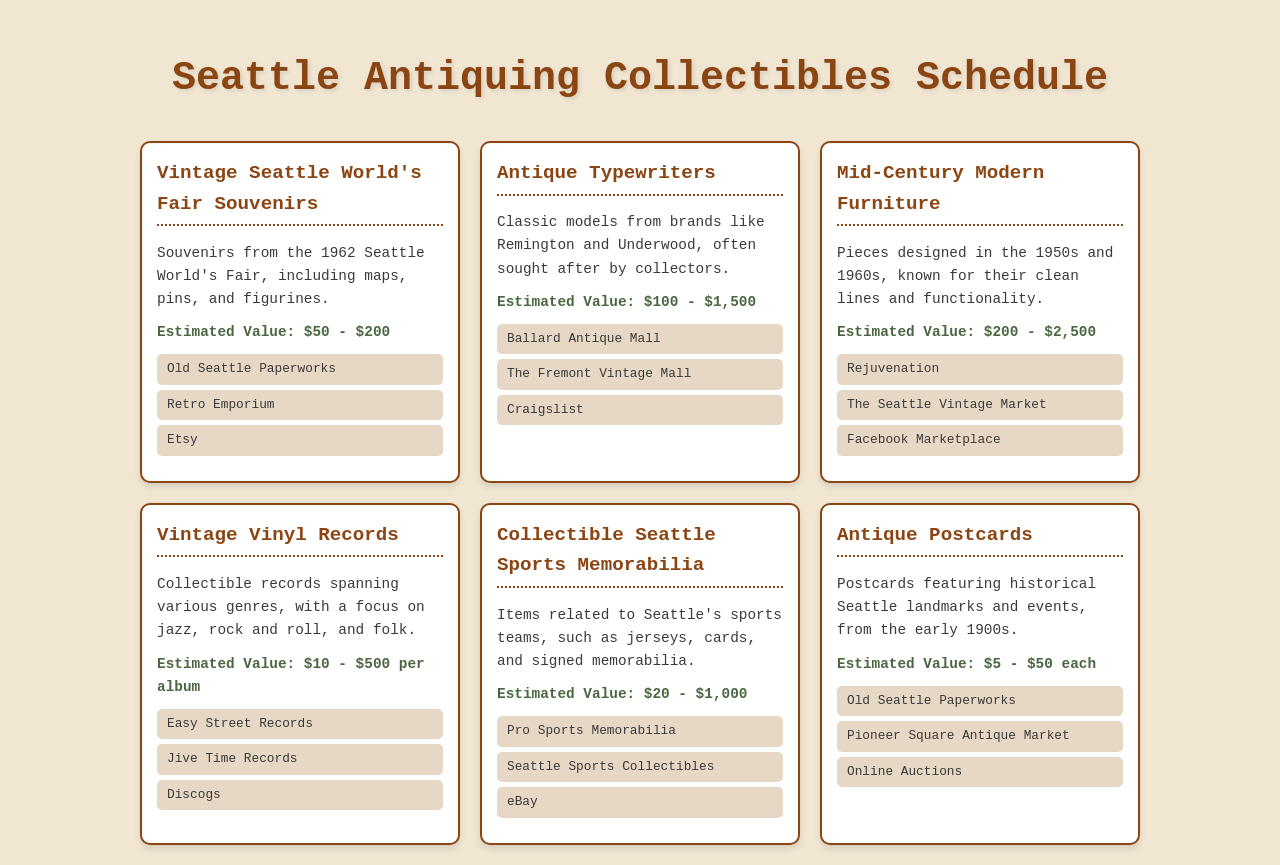What item has an estimated value of $50 - $200? The document lists "Vintage Seattle World's Fair Souvenirs" with this estimated value.
Answer: Vintage Seattle World's Fair Souvenirs How many sellers are listed for Antique Typewriters? The document provides three sellers for this item.
Answer: 3 What is the highest estimated value for Mid-Century Modern Furniture? The document mentions that the estimated value can go up to $2,500.
Answer: $2,500 Which seller is common for Vintage Seattle World's Fair Souvenirs and Antique Postcards? Both items list "Old Seattle Paperworks" as a seller.
Answer: Old Seattle Paperworks What collectible item has an estimated value per album? The document states that "Vintage Vinyl Records" have an estimated value per album.
Answer: Vintage Vinyl Records 